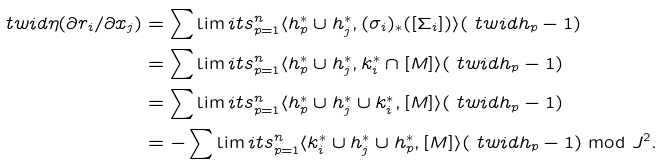Convert formula to latex. <formula><loc_0><loc_0><loc_500><loc_500>\ t w i d { \eta } ( \partial r _ { i } / \partial x _ { j } ) & = \sum \lim i t s _ { p = 1 } ^ { n } \langle h ^ { * } _ { p } \cup h ^ { * } _ { j } , ( \sigma _ { i } ) _ { * } ( [ \Sigma _ { i } ] ) \rangle ( \ t w i d { h } _ { p } - 1 ) \\ & = \sum \lim i t s _ { p = 1 } ^ { n } \langle h ^ { * } _ { p } \cup h ^ { * } _ { j } , k ^ { * } _ { i } \cap [ M ] \rangle ( \ t w i d { h } _ { p } - 1 ) \\ & = \sum \lim i t s _ { p = 1 } ^ { n } \langle h ^ { * } _ { p } \cup h ^ { * } _ { j } \cup k ^ { * } _ { i } , [ M ] \rangle ( \ t w i d { h } _ { p } - 1 ) \\ & = - \sum \lim i t s _ { p = 1 } ^ { n } \langle k ^ { * } _ { i } \cup h ^ { * } _ { j } \cup h ^ { * } _ { p } , [ M ] \rangle ( \ t w i d { h } _ { p } - 1 ) \bmod J ^ { 2 } .</formula> 